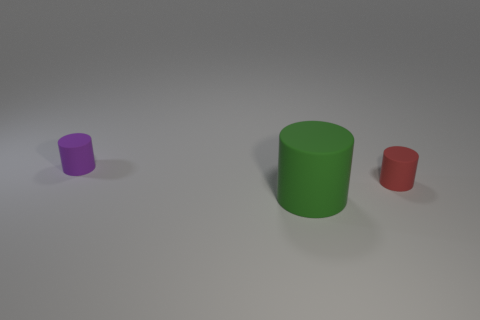Can you describe the shapes and colors of the objects in the image? Certainly! The image showcases three cylindrical-shaped objects, each with a distinct height and color. The smallest cylinder is purple, the medium-sized one is green, and the largest cylinder is red. They are presented against a neutral gray background, which enhances the visibility of their colors. 